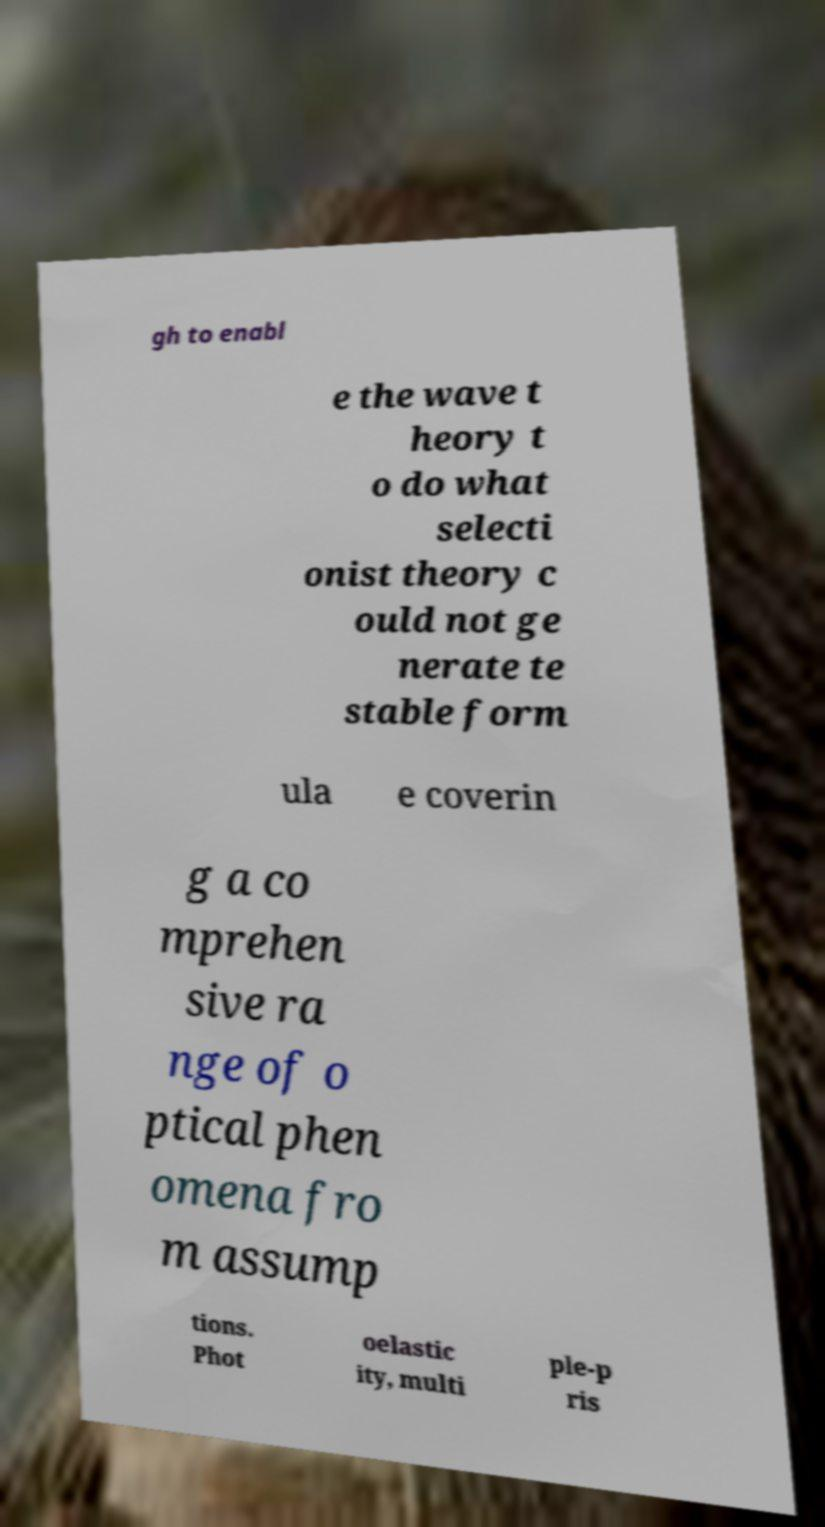What messages or text are displayed in this image? I need them in a readable, typed format. gh to enabl e the wave t heory t o do what selecti onist theory c ould not ge nerate te stable form ula e coverin g a co mprehen sive ra nge of o ptical phen omena fro m assump tions. Phot oelastic ity, multi ple-p ris 